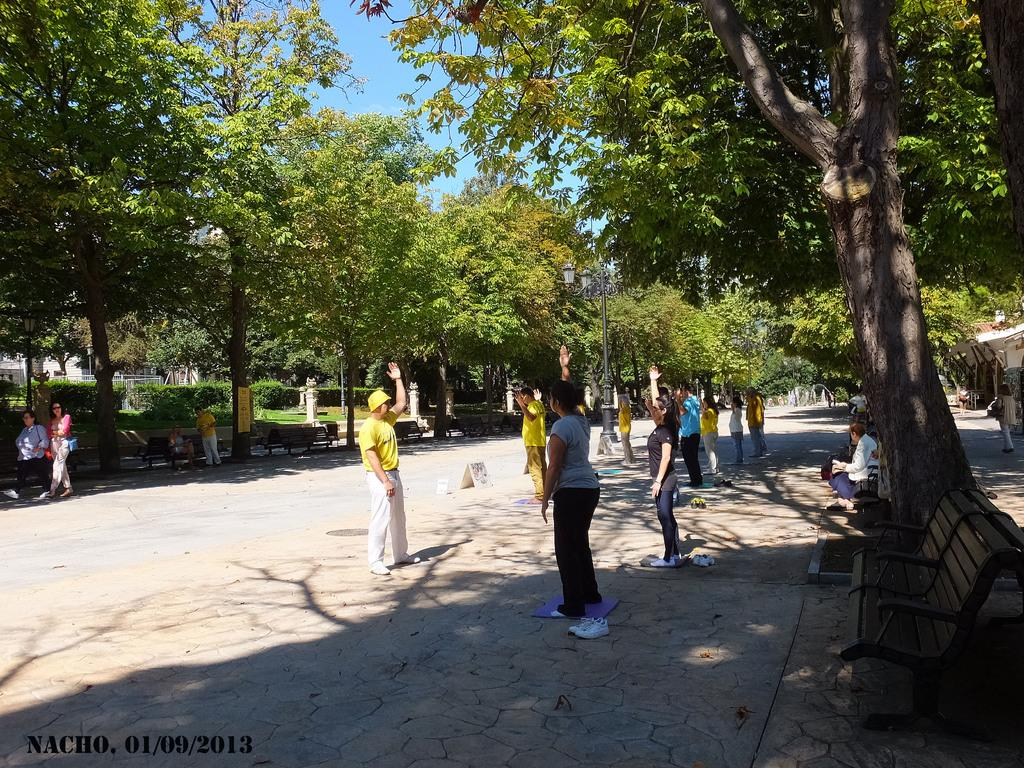What is the main feature of the image? There is a road in the image. What are the people on the road doing? The people are doing exercise on the road. What can be seen on both sides of the road? There are trees on either side of the road. What type of popcorn is being sold on the side of the road in the image? There is no popcorn being sold on the side of the road in the image. What is the value of the exercise equipment being used by the people in the image? The image does not provide any information about the value of the exercise equipment being used by the people. 